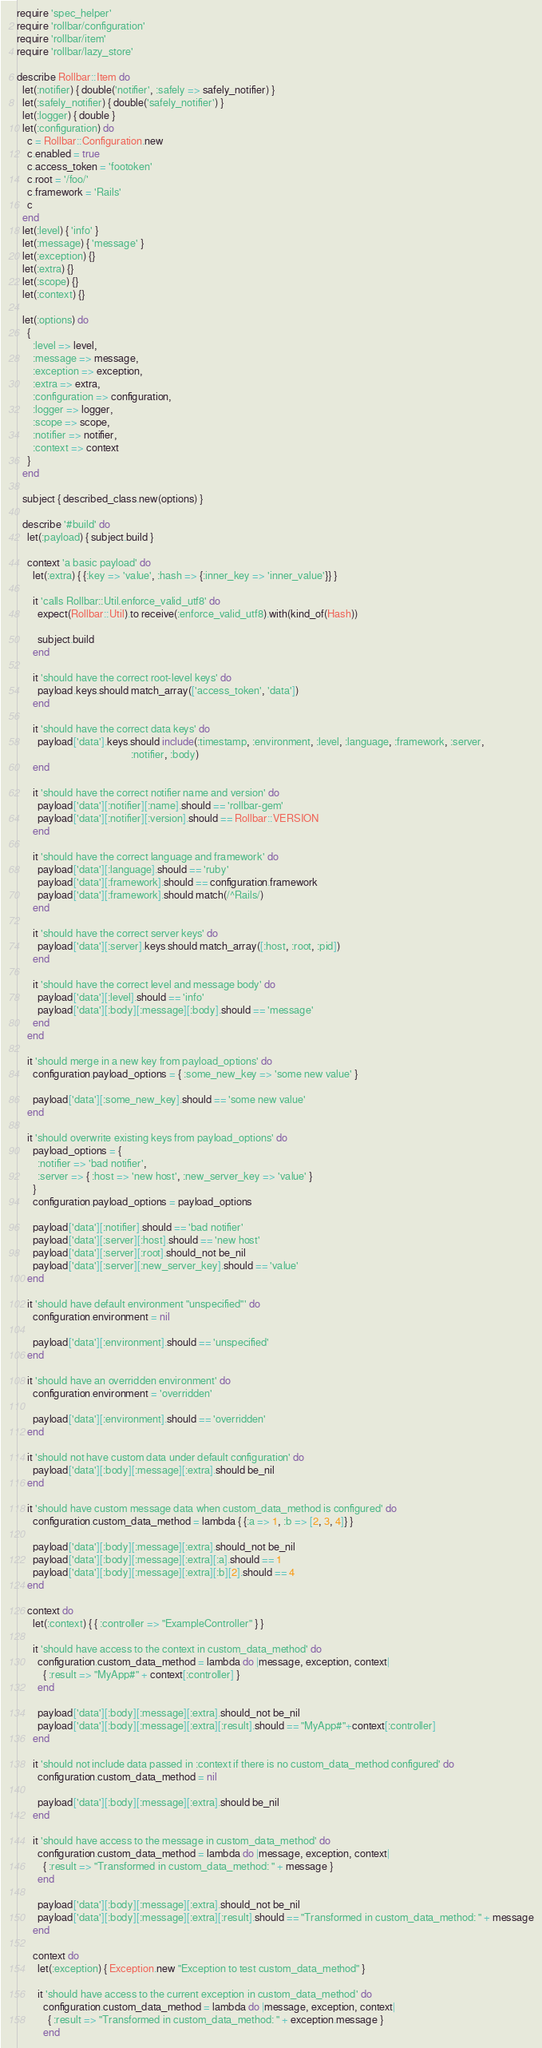Convert code to text. <code><loc_0><loc_0><loc_500><loc_500><_Ruby_>require 'spec_helper'
require 'rollbar/configuration'
require 'rollbar/item'
require 'rollbar/lazy_store'

describe Rollbar::Item do
  let(:notifier) { double('notifier', :safely => safely_notifier) }
  let(:safely_notifier) { double('safely_notifier') }
  let(:logger) { double }
  let(:configuration) do
    c = Rollbar::Configuration.new
    c.enabled = true
    c.access_token = 'footoken'
    c.root = '/foo/'
    c.framework = 'Rails'
    c
  end
  let(:level) { 'info' }
  let(:message) { 'message' }
  let(:exception) {}
  let(:extra) {}
  let(:scope) {}
  let(:context) {}

  let(:options) do
    {
      :level => level,
      :message => message,
      :exception => exception,
      :extra => extra,
      :configuration => configuration,
      :logger => logger,
      :scope => scope,
      :notifier => notifier,
      :context => context
    }
  end

  subject { described_class.new(options) }

  describe '#build' do
    let(:payload) { subject.build }

    context 'a basic payload' do
      let(:extra) { {:key => 'value', :hash => {:inner_key => 'inner_value'}} }

      it 'calls Rollbar::Util.enforce_valid_utf8' do
        expect(Rollbar::Util).to receive(:enforce_valid_utf8).with(kind_of(Hash))

        subject.build
      end

      it 'should have the correct root-level keys' do
        payload.keys.should match_array(['access_token', 'data'])
      end

      it 'should have the correct data keys' do
        payload['data'].keys.should include(:timestamp, :environment, :level, :language, :framework, :server,
                                            :notifier, :body)
      end

      it 'should have the correct notifier name and version' do
        payload['data'][:notifier][:name].should == 'rollbar-gem'
        payload['data'][:notifier][:version].should == Rollbar::VERSION
      end

      it 'should have the correct language and framework' do
        payload['data'][:language].should == 'ruby'
        payload['data'][:framework].should == configuration.framework
        payload['data'][:framework].should match(/^Rails/)
      end

      it 'should have the correct server keys' do
        payload['data'][:server].keys.should match_array([:host, :root, :pid])
      end

      it 'should have the correct level and message body' do
        payload['data'][:level].should == 'info'
        payload['data'][:body][:message][:body].should == 'message'
      end
    end

    it 'should merge in a new key from payload_options' do
      configuration.payload_options = { :some_new_key => 'some new value' }

      payload['data'][:some_new_key].should == 'some new value'
    end

    it 'should overwrite existing keys from payload_options' do
      payload_options = {
        :notifier => 'bad notifier',
        :server => { :host => 'new host', :new_server_key => 'value' }
      }
      configuration.payload_options = payload_options

      payload['data'][:notifier].should == 'bad notifier'
      payload['data'][:server][:host].should == 'new host'
      payload['data'][:server][:root].should_not be_nil
      payload['data'][:server][:new_server_key].should == 'value'
    end

    it 'should have default environment "unspecified"' do
      configuration.environment = nil

      payload['data'][:environment].should == 'unspecified'
    end

    it 'should have an overridden environment' do
      configuration.environment = 'overridden'

      payload['data'][:environment].should == 'overridden'
    end

    it 'should not have custom data under default configuration' do
      payload['data'][:body][:message][:extra].should be_nil
    end

    it 'should have custom message data when custom_data_method is configured' do
      configuration.custom_data_method = lambda { {:a => 1, :b => [2, 3, 4]} }

      payload['data'][:body][:message][:extra].should_not be_nil
      payload['data'][:body][:message][:extra][:a].should == 1
      payload['data'][:body][:message][:extra][:b][2].should == 4
    end

    context do
      let(:context) { { :controller => "ExampleController" } }

      it 'should have access to the context in custom_data_method' do
        configuration.custom_data_method = lambda do |message, exception, context|
          { :result => "MyApp#" + context[:controller] }
        end

        payload['data'][:body][:message][:extra].should_not be_nil
        payload['data'][:body][:message][:extra][:result].should == "MyApp#"+context[:controller]
      end

      it 'should not include data passed in :context if there is no custom_data_method configured' do
        configuration.custom_data_method = nil

        payload['data'][:body][:message][:extra].should be_nil
      end

      it 'should have access to the message in custom_data_method' do
        configuration.custom_data_method = lambda do |message, exception, context|
          { :result => "Transformed in custom_data_method: " + message }
        end

        payload['data'][:body][:message][:extra].should_not be_nil
        payload['data'][:body][:message][:extra][:result].should == "Transformed in custom_data_method: " + message
      end

      context do
        let(:exception) { Exception.new "Exception to test custom_data_method" }

        it 'should have access to the current exception in custom_data_method' do
          configuration.custom_data_method = lambda do |message, exception, context|
            { :result => "Transformed in custom_data_method: " + exception.message }
          end
</code> 